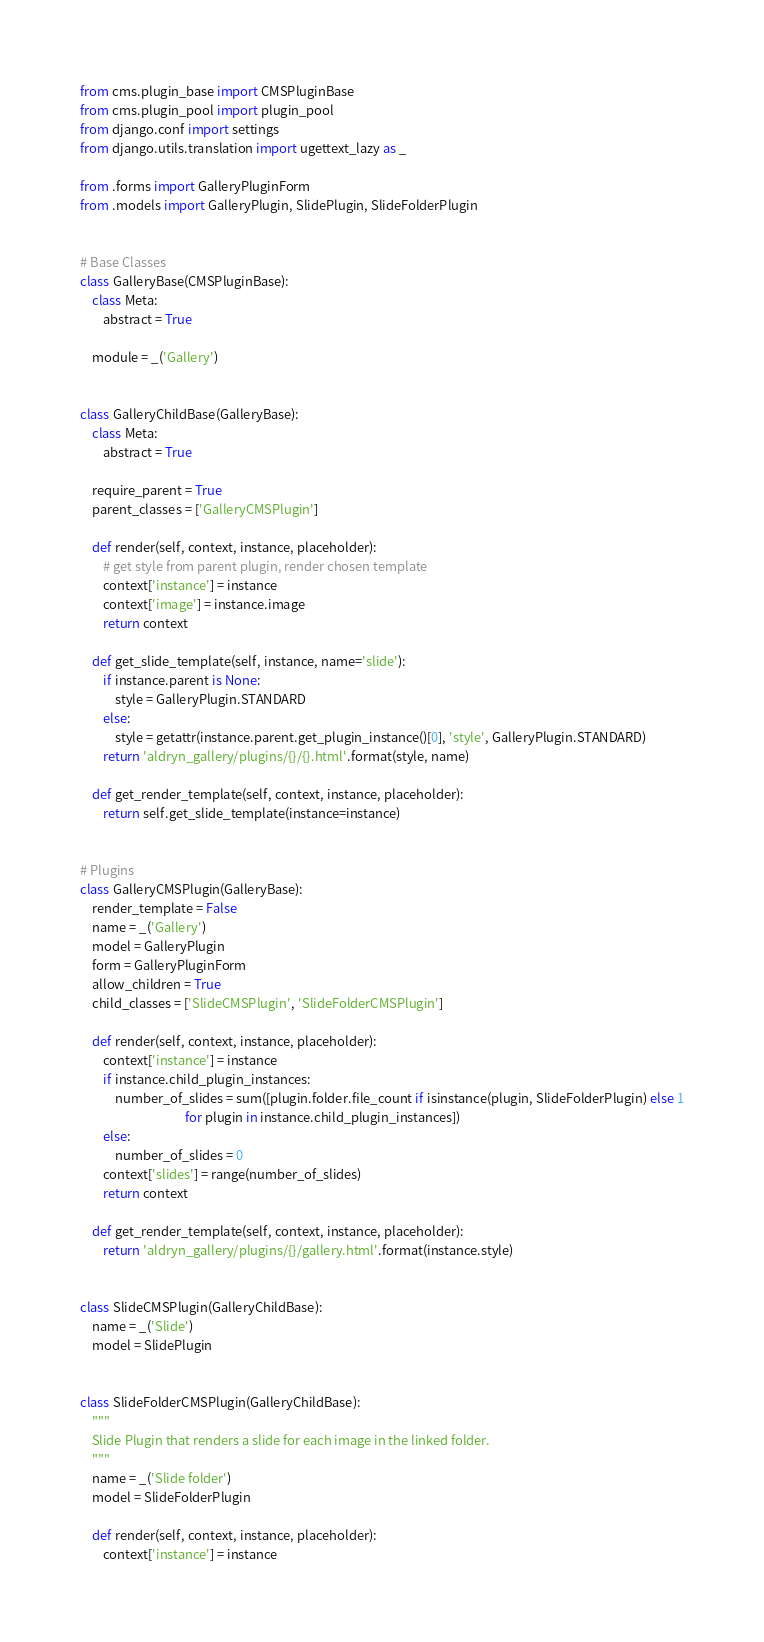<code> <loc_0><loc_0><loc_500><loc_500><_Python_>from cms.plugin_base import CMSPluginBase
from cms.plugin_pool import plugin_pool
from django.conf import settings
from django.utils.translation import ugettext_lazy as _

from .forms import GalleryPluginForm
from .models import GalleryPlugin, SlidePlugin, SlideFolderPlugin


# Base Classes
class GalleryBase(CMSPluginBase):
    class Meta:
        abstract = True

    module = _('Gallery')


class GalleryChildBase(GalleryBase):
    class Meta:
        abstract = True

    require_parent = True
    parent_classes = ['GalleryCMSPlugin']

    def render(self, context, instance, placeholder):
        # get style from parent plugin, render chosen template
        context['instance'] = instance
        context['image'] = instance.image
        return context

    def get_slide_template(self, instance, name='slide'):
        if instance.parent is None:
            style = GalleryPlugin.STANDARD
        else:
            style = getattr(instance.parent.get_plugin_instance()[0], 'style', GalleryPlugin.STANDARD)
        return 'aldryn_gallery/plugins/{}/{}.html'.format(style, name)

    def get_render_template(self, context, instance, placeholder):
        return self.get_slide_template(instance=instance)


# Plugins
class GalleryCMSPlugin(GalleryBase):
    render_template = False
    name = _('Gallery')
    model = GalleryPlugin
    form = GalleryPluginForm
    allow_children = True
    child_classes = ['SlideCMSPlugin', 'SlideFolderCMSPlugin']

    def render(self, context, instance, placeholder):
        context['instance'] = instance
        if instance.child_plugin_instances:
            number_of_slides = sum([plugin.folder.file_count if isinstance(plugin, SlideFolderPlugin) else 1
                                    for plugin in instance.child_plugin_instances])
        else:
            number_of_slides = 0
        context['slides'] = range(number_of_slides)
        return context

    def get_render_template(self, context, instance, placeholder):
        return 'aldryn_gallery/plugins/{}/gallery.html'.format(instance.style)


class SlideCMSPlugin(GalleryChildBase):
    name = _('Slide')
    model = SlidePlugin


class SlideFolderCMSPlugin(GalleryChildBase):
    """
    Slide Plugin that renders a slide for each image in the linked folder.
    """
    name = _('Slide folder')
    model = SlideFolderPlugin

    def render(self, context, instance, placeholder):
        context['instance'] = instance</code> 